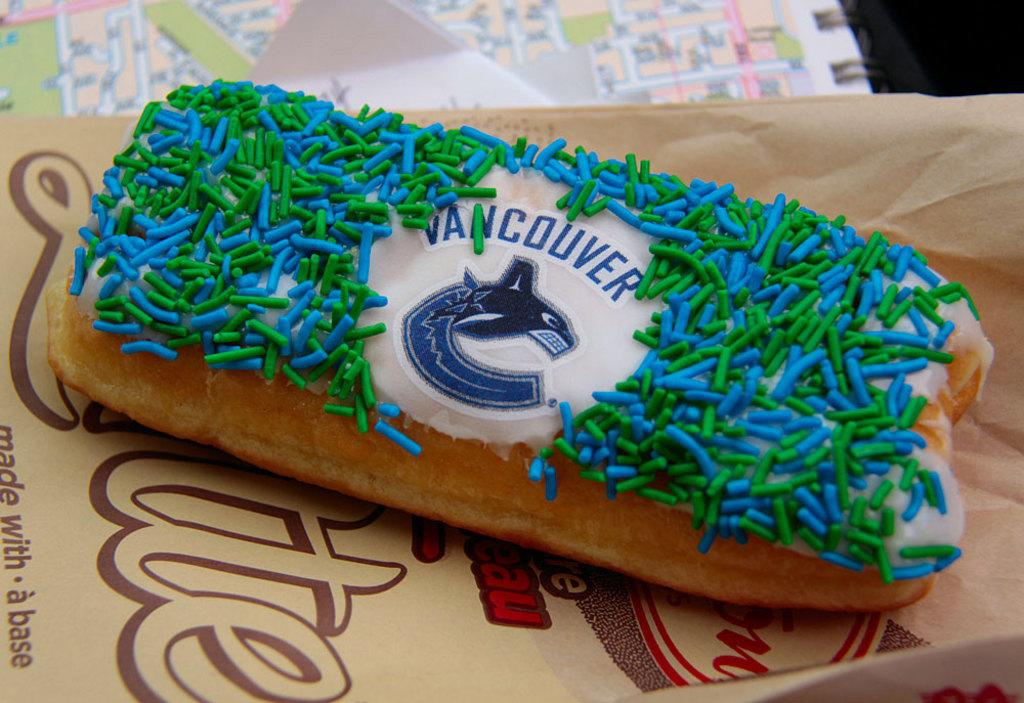What is located at the bottom of the image? There is a table at the bottom of the image. What is on the table? There is a paper on the table. What is on the paper? There is food on the paper. What type of crime is being committed in the image? There is no indication of any crime being committed in the image. Who is the owner of the food in the image? The image does not provide information about the ownership of the food. 